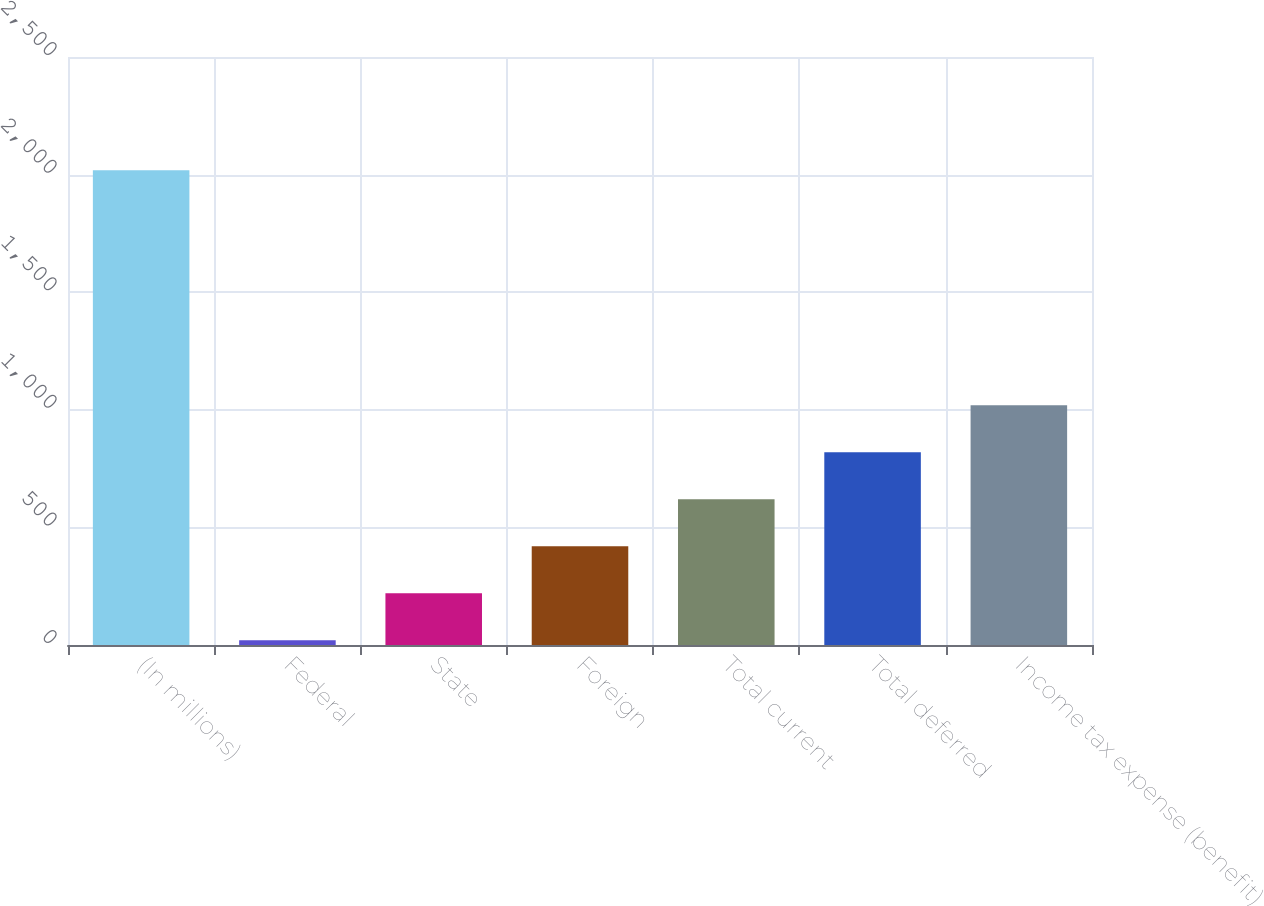<chart> <loc_0><loc_0><loc_500><loc_500><bar_chart><fcel>(In millions)<fcel>Federal<fcel>State<fcel>Foreign<fcel>Total current<fcel>Total deferred<fcel>Income tax expense (benefit)<nl><fcel>2019<fcel>20<fcel>219.9<fcel>419.8<fcel>619.7<fcel>819.6<fcel>1019.5<nl></chart> 